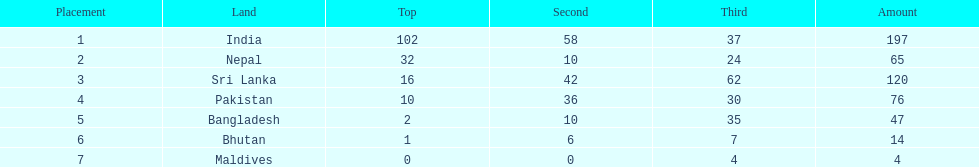How many countries have one more than 10 gold medals? 3. 